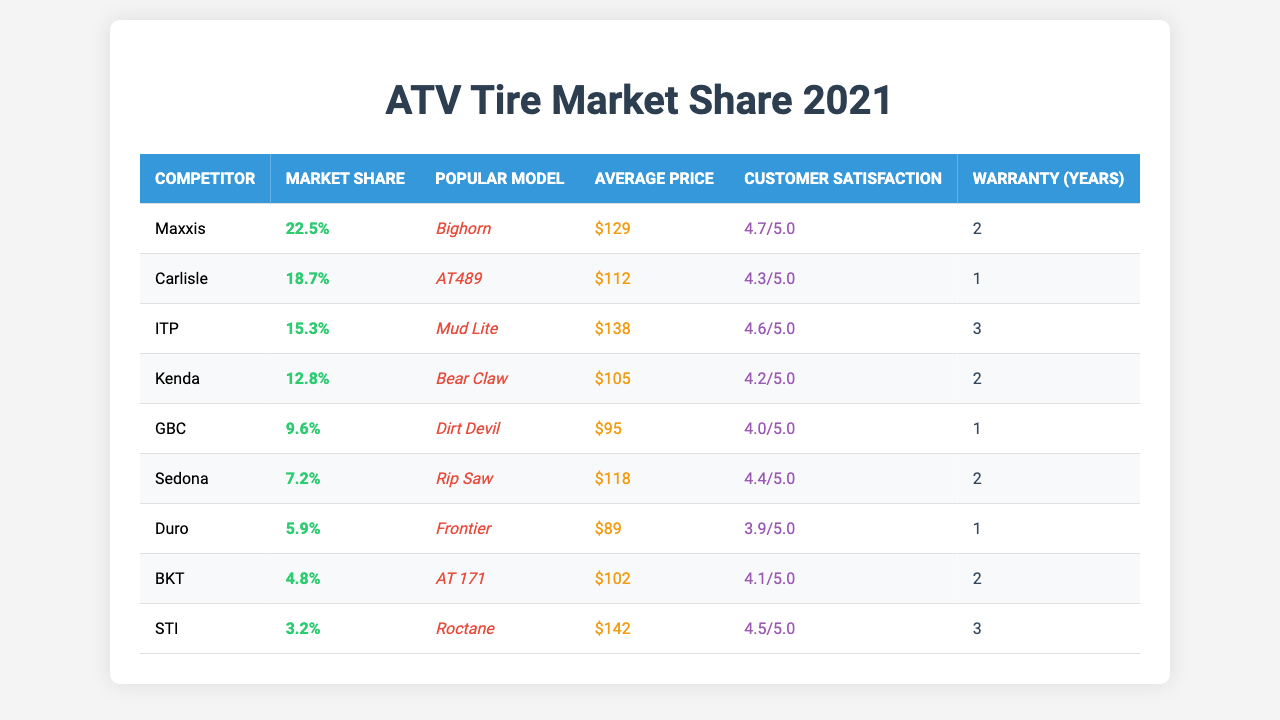What is the market share of Maxxis? The table lists Maxxis with a market share of 22.5%.
Answer: 22.5% Which competitor has the highest customer satisfaction? Reviewing the customer satisfaction ratings, Maxxis has the highest score of 4.7 out of 5.0.
Answer: 4.7 What is the average price of Kenda tires? The average price for Kenda tires is listed in the table as $105.
Answer: $105 Which competitor has the longest warranty, and what is the duration? Both ITP and GBC have the longest warranty of 3 years.
Answer: ITP and GBC, 3 years What is the market share difference between the highest and lowest competitors? The highest is Maxxis at 22.5%, and the lowest is STI at 3.2%. The difference is 22.5% - 3.2% = 19.3%.
Answer: 19.3% What is the average market share of all competitors? To find the average market share, sum all market shares (22.5 + 18.7 + 15.3 + 12.8 + 9.6 + 7.2 + 5.9 + 4.8 + 3.2) = 94.0%. Then divide by 9 competitors: 94.0% / 9 = approximately 10.44%.
Answer: 10.44% Is the average price of GBC tires lower than the average price of STI tires? The average price of GBC is $95, while STI is $142, so $95 < $142 is true.
Answer: Yes What percentage of the total market share do Duro and BKT hold together? Duro has 5.9% and BKT has 4.8%, adding them gives 5.9% + 4.8% = 10.7%.
Answer: 10.7% What is the most popular model among competitors? The most popular model according to the table is Bighorn by Maxxis.
Answer: Bighorn Which competitor has the best balance of market share and customer satisfaction? Maxxis has the highest market share (22.5%) and also the highest customer satisfaction (4.7), making it the best balance.
Answer: Maxxis 